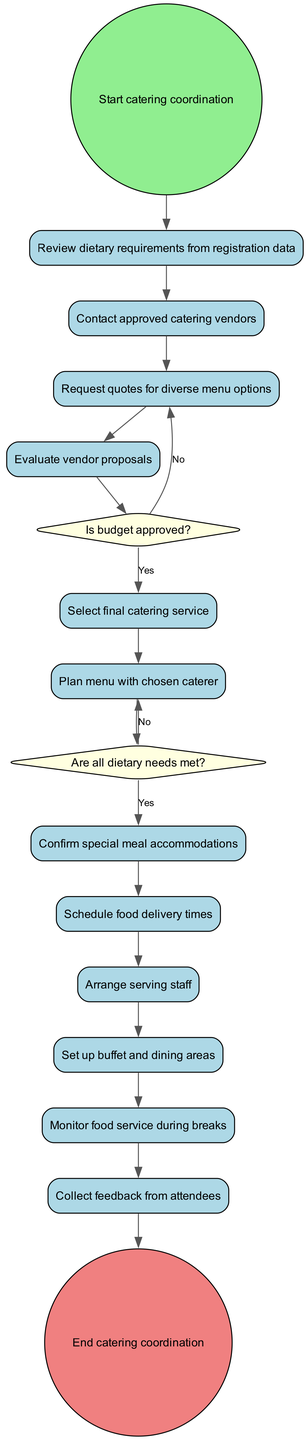What is the initial node in the diagram? The initial node is labeled "Start catering coordination," which indicates the starting point of the catering coordination process.
Answer: Start catering coordination How many activities are listed in the diagram? The diagram contains a total of 12 activities, as counted from the activities section of the provided data.
Answer: 12 What is the first activity after the initial node? The first activity listed after the initial node is "Review dietary requirements from registration data." This is the first step in the catering coordination process.
Answer: Review dietary requirements from registration data What happens if the dietary needs are not met after planning the menu? If the dietary needs are not met, the decision leads to "Adjust menu options," indicating that further changes to the menu are required to accommodate all attendees.
Answer: Adjust menu options What is the final outcome of the diagram? The final outcome of the diagram is labeled "End catering coordination," indicating the completion of the catering coordination process.
Answer: End catering coordination Which activity comes just before the decision about the budget approval? The activity that occurs just before the budget approval decision is "Evaluate vendor proposals," as it leads to the decision node that checks if the budget is approved.
Answer: Evaluate vendor proposals How many decision points are present in the diagram? There are two decision points present in the diagram, which are focused on whether dietary needs are met and whether the budget is approved.
Answer: 2 What activity follows after confirming special meal accommodations? The activity that follows after confirming special meal accommodations is "Schedule food delivery times," as indicated in the flow of the diagram.
Answer: Schedule food delivery times What question is posed to evaluate dietary needs? The specific question posed to evaluate dietary needs is "Are all dietary needs met?" This question is crucial for finalizing the catering plan.
Answer: Are all dietary needs met? 